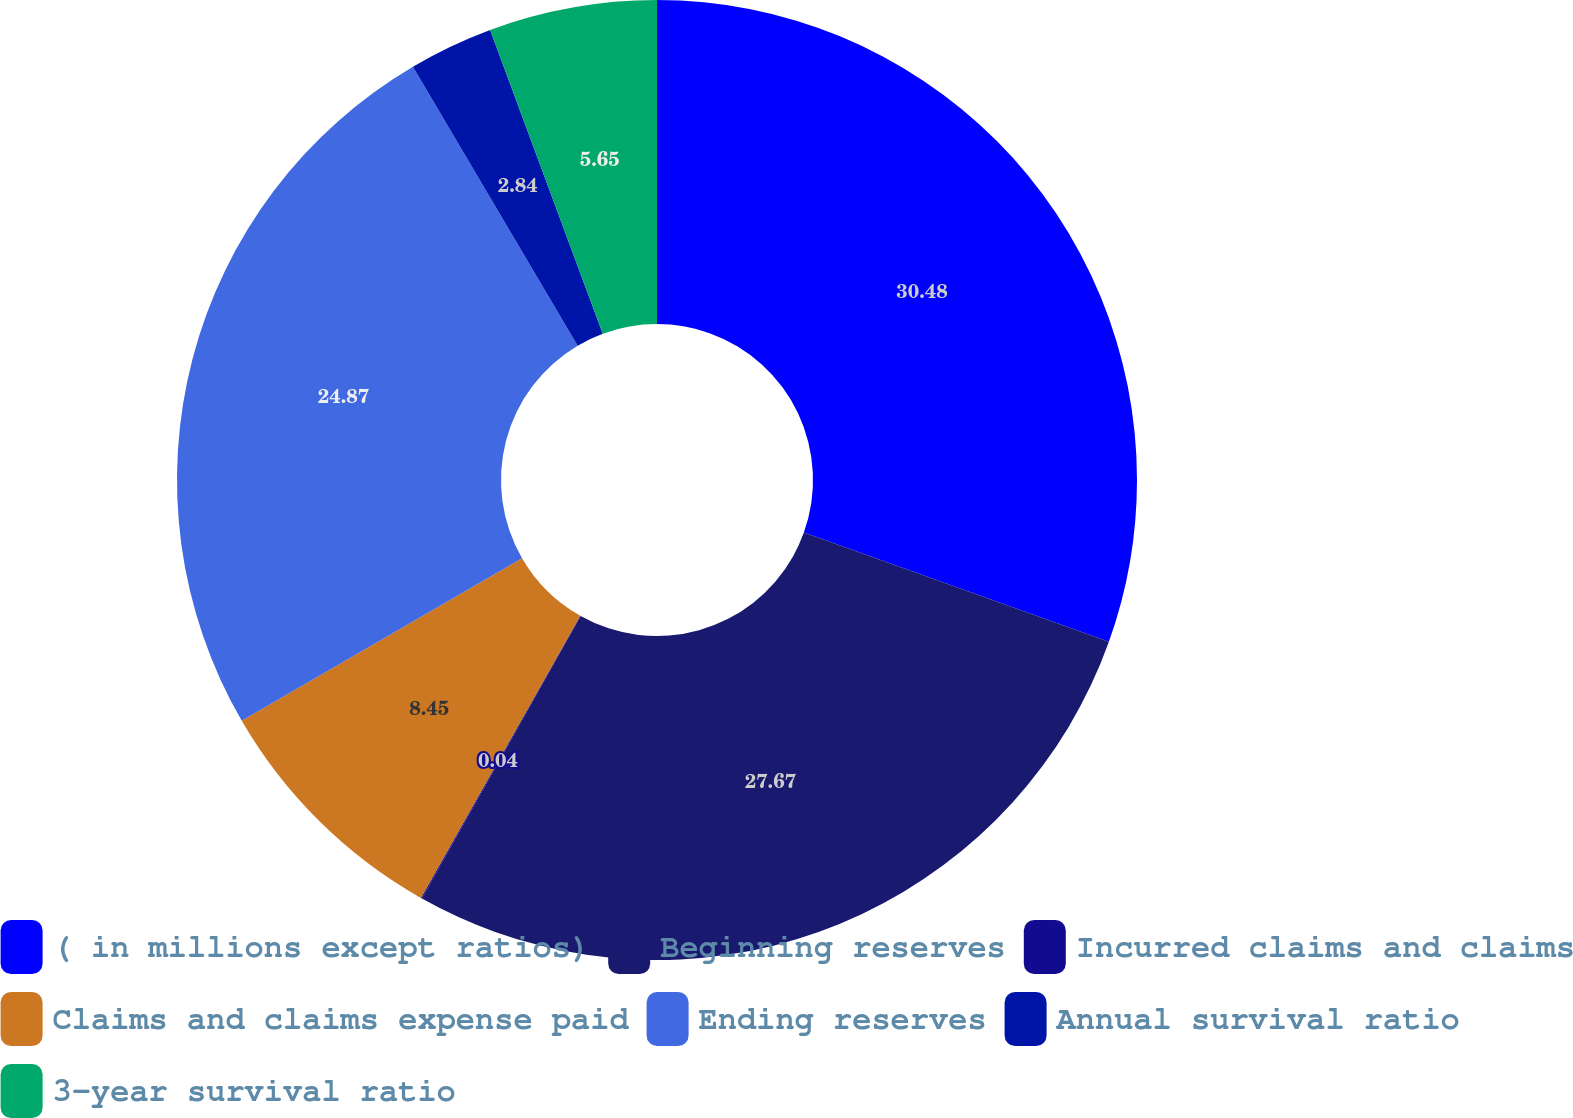Convert chart to OTSL. <chart><loc_0><loc_0><loc_500><loc_500><pie_chart><fcel>( in millions except ratios)<fcel>Beginning reserves<fcel>Incurred claims and claims<fcel>Claims and claims expense paid<fcel>Ending reserves<fcel>Annual survival ratio<fcel>3-year survival ratio<nl><fcel>30.47%<fcel>27.67%<fcel>0.04%<fcel>8.45%<fcel>24.87%<fcel>2.84%<fcel>5.65%<nl></chart> 